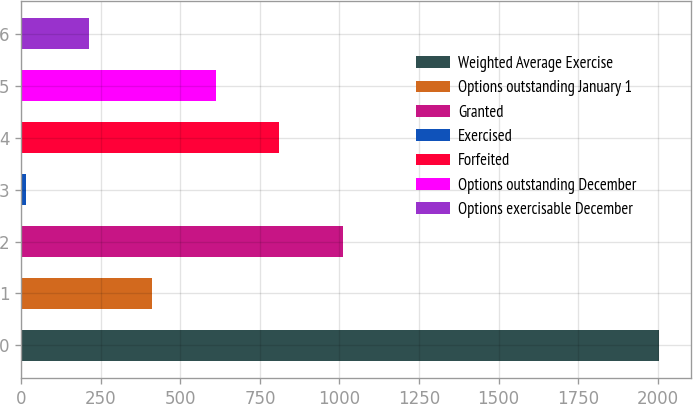Convert chart to OTSL. <chart><loc_0><loc_0><loc_500><loc_500><bar_chart><fcel>Weighted Average Exercise<fcel>Options outstanding January 1<fcel>Granted<fcel>Exercised<fcel>Forfeited<fcel>Options outstanding December<fcel>Options exercisable December<nl><fcel>2006<fcel>412.15<fcel>1009.84<fcel>13.69<fcel>810.61<fcel>611.38<fcel>212.92<nl></chart> 